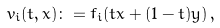<formula> <loc_0><loc_0><loc_500><loc_500>v _ { i } ( t , x ) & \colon = f _ { i } ( t x + ( 1 - t ) y ) \, ,</formula> 